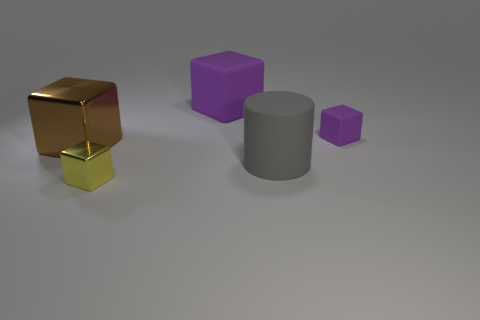Is the color of the tiny thing that is to the right of the tiny yellow metallic thing the same as the large matte object that is behind the big metallic block?
Give a very brief answer. Yes. There is a thing that is the same color as the small rubber block; what is its size?
Keep it short and to the point. Large. What number of other objects are the same shape as the gray thing?
Offer a terse response. 0. Is the number of big green rubber objects less than the number of big purple rubber cubes?
Provide a succinct answer. Yes. What size is the rubber object that is in front of the big purple rubber cube and behind the matte cylinder?
Your answer should be compact. Small. How big is the purple matte thing in front of the purple cube behind the block that is right of the big rubber cube?
Offer a very short reply. Small. How big is the brown metallic thing?
Keep it short and to the point. Large. There is a small thing on the right side of the big rubber thing in front of the tiny rubber thing; are there any purple matte cubes that are behind it?
Ensure brevity in your answer.  Yes. What number of small things are metal things or purple blocks?
Offer a very short reply. 2. Is there anything else of the same color as the tiny matte block?
Offer a terse response. Yes. 